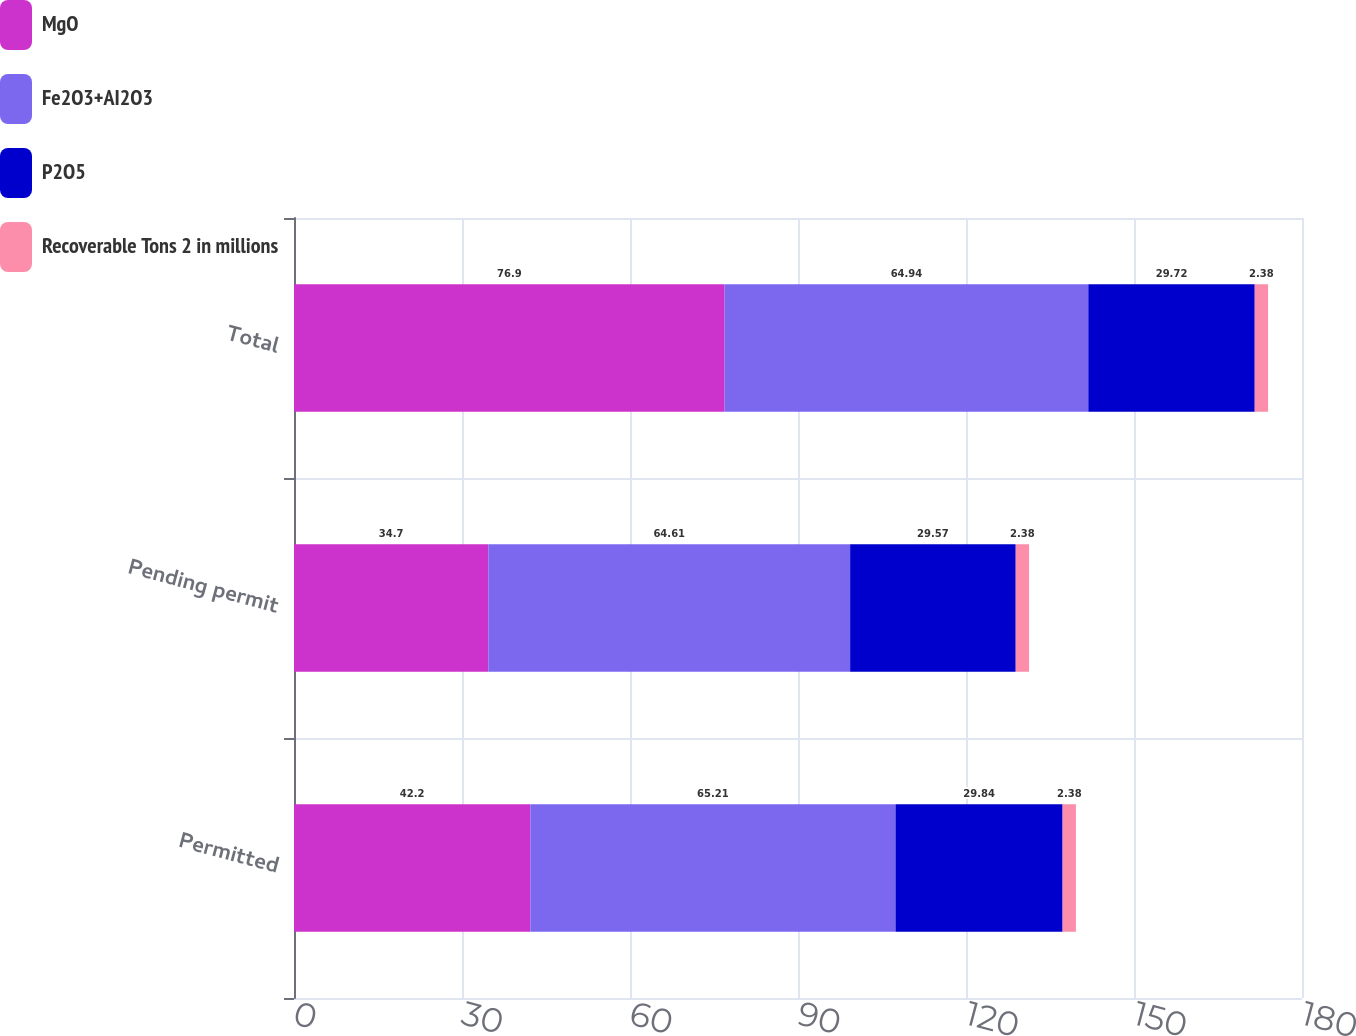<chart> <loc_0><loc_0><loc_500><loc_500><stacked_bar_chart><ecel><fcel>Permitted<fcel>Pending permit<fcel>Total<nl><fcel>MgO<fcel>42.2<fcel>34.7<fcel>76.9<nl><fcel>Fe2O3+AI2O3<fcel>65.21<fcel>64.61<fcel>64.94<nl><fcel>P2O5<fcel>29.84<fcel>29.57<fcel>29.72<nl><fcel>Recoverable Tons 2 in millions<fcel>2.38<fcel>2.38<fcel>2.38<nl></chart> 